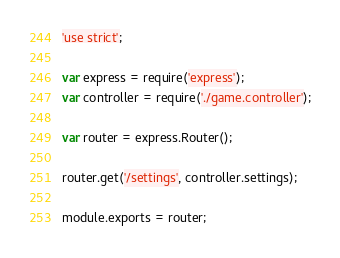Convert code to text. <code><loc_0><loc_0><loc_500><loc_500><_JavaScript_>'use strict';

var express = require('express');
var controller = require('./game.controller');

var router = express.Router();

router.get('/settings', controller.settings);

module.exports = router;</code> 